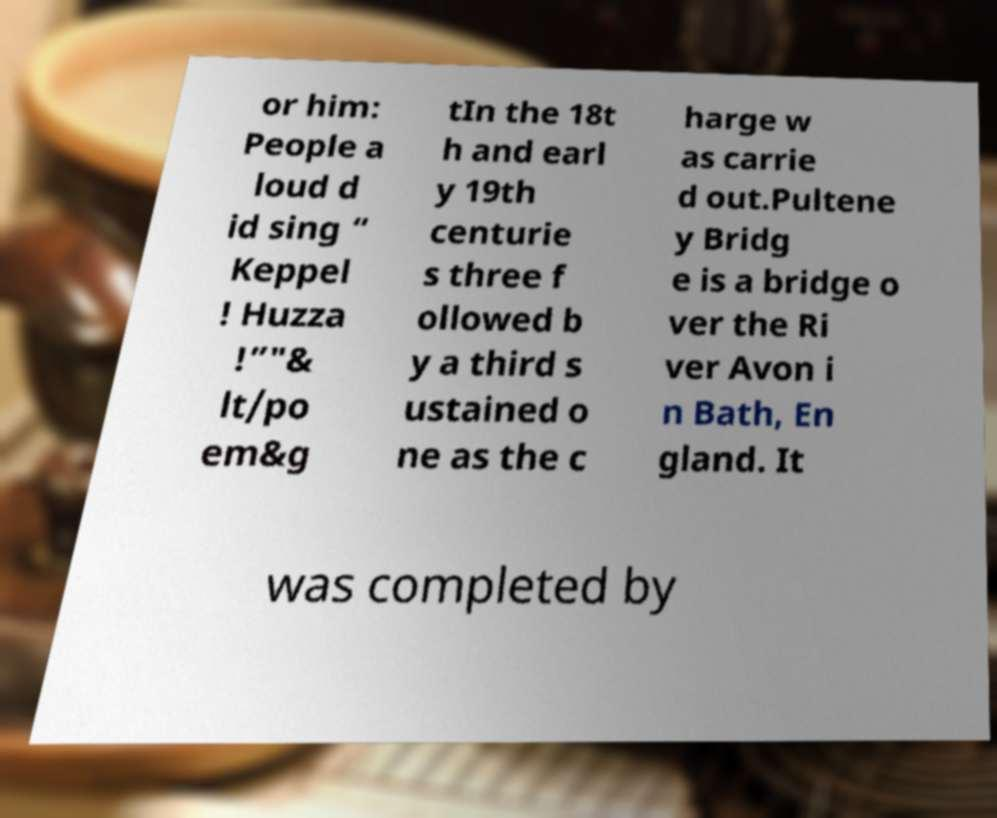Please identify and transcribe the text found in this image. or him: People a loud d id sing “ Keppel ! Huzza !”"& lt/po em&g tIn the 18t h and earl y 19th centurie s three f ollowed b y a third s ustained o ne as the c harge w as carrie d out.Pultene y Bridg e is a bridge o ver the Ri ver Avon i n Bath, En gland. It was completed by 